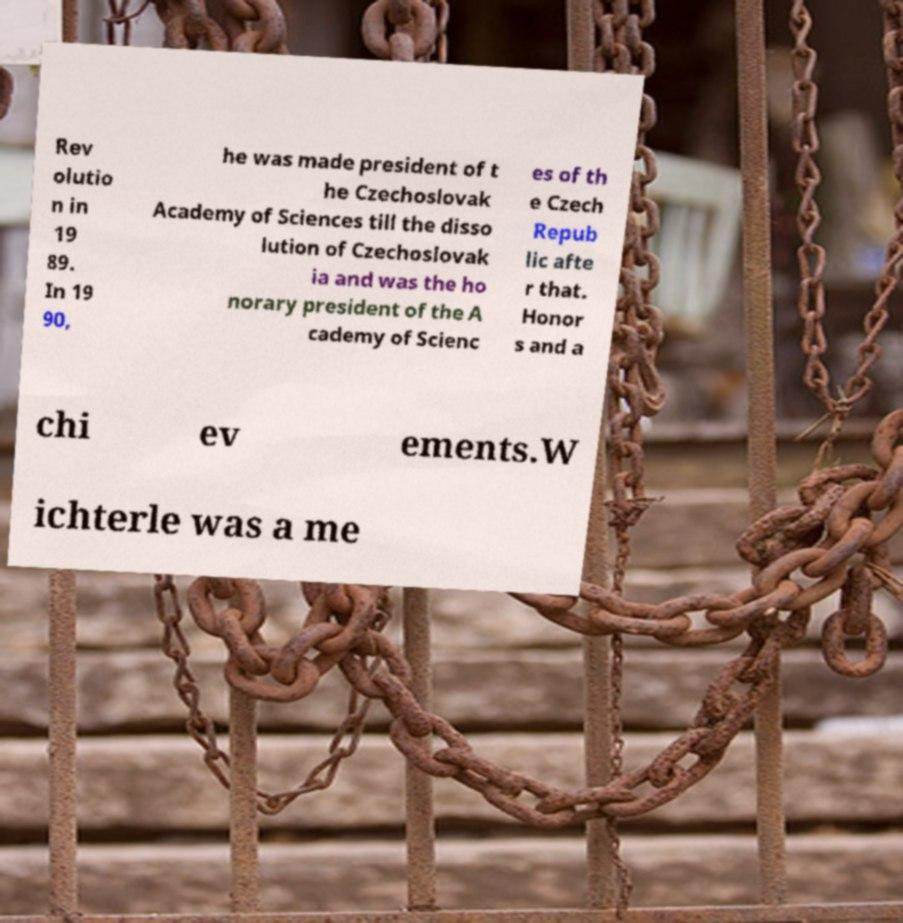Can you read and provide the text displayed in the image?This photo seems to have some interesting text. Can you extract and type it out for me? Rev olutio n in 19 89. In 19 90, he was made president of t he Czechoslovak Academy of Sciences till the disso lution of Czechoslovak ia and was the ho norary president of the A cademy of Scienc es of th e Czech Repub lic afte r that. Honor s and a chi ev ements.W ichterle was a me 